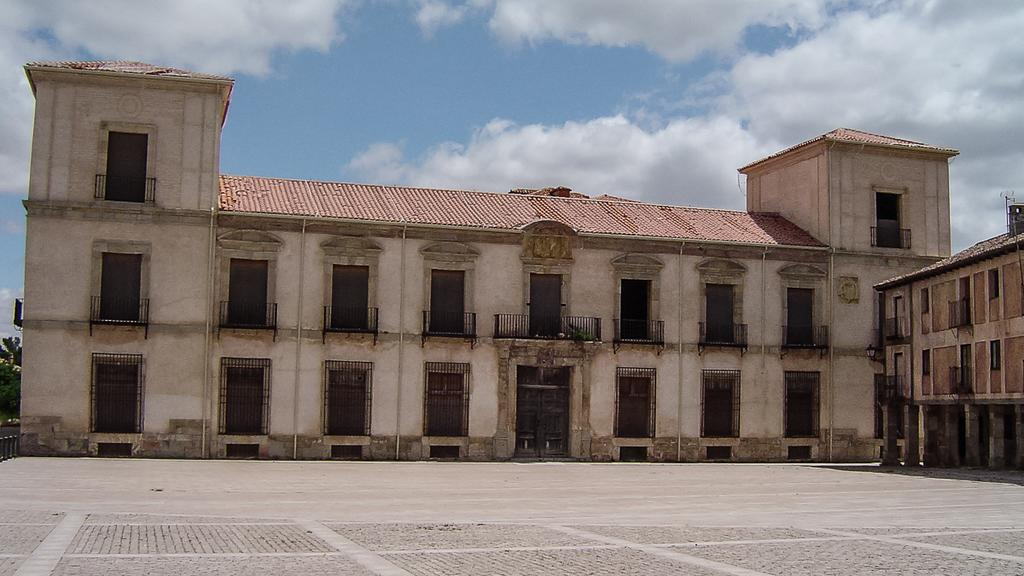What can be seen at the bottom of the image? The ground is visible in the image. What is visible in the distance behind the main subject? There are buildings and trees in the background of the image. What part of the natural environment is visible in the image? The sky is visible in the background of the image, and clouds are present in the sky. Can you tell me how much credit the queen is offering in the image? There is no mention of credit or a queen in the image; it features a landscape with buildings, trees, and a sky with clouds. 